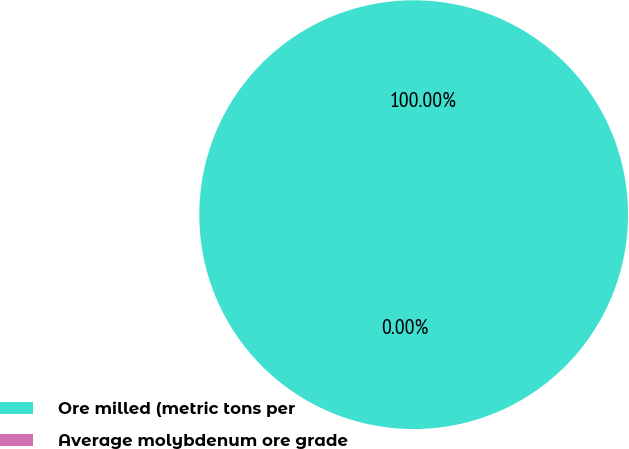Convert chart. <chart><loc_0><loc_0><loc_500><loc_500><pie_chart><fcel>Ore milled (metric tons per<fcel>Average molybdenum ore grade<nl><fcel>100.0%<fcel>0.0%<nl></chart> 